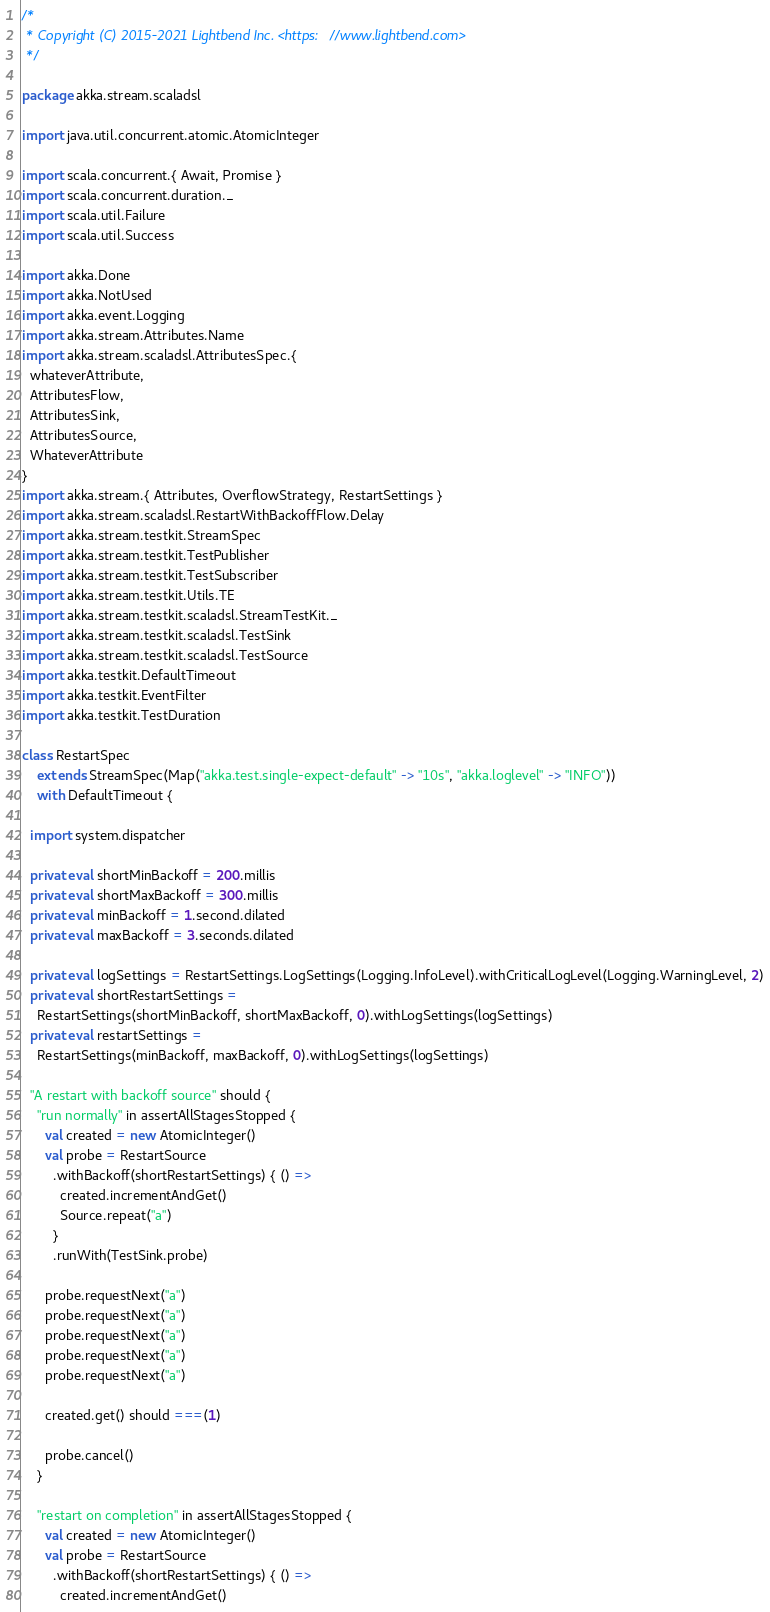<code> <loc_0><loc_0><loc_500><loc_500><_Scala_>/*
 * Copyright (C) 2015-2021 Lightbend Inc. <https://www.lightbend.com>
 */

package akka.stream.scaladsl

import java.util.concurrent.atomic.AtomicInteger

import scala.concurrent.{ Await, Promise }
import scala.concurrent.duration._
import scala.util.Failure
import scala.util.Success

import akka.Done
import akka.NotUsed
import akka.event.Logging
import akka.stream.Attributes.Name
import akka.stream.scaladsl.AttributesSpec.{
  whateverAttribute,
  AttributesFlow,
  AttributesSink,
  AttributesSource,
  WhateverAttribute
}
import akka.stream.{ Attributes, OverflowStrategy, RestartSettings }
import akka.stream.scaladsl.RestartWithBackoffFlow.Delay
import akka.stream.testkit.StreamSpec
import akka.stream.testkit.TestPublisher
import akka.stream.testkit.TestSubscriber
import akka.stream.testkit.Utils.TE
import akka.stream.testkit.scaladsl.StreamTestKit._
import akka.stream.testkit.scaladsl.TestSink
import akka.stream.testkit.scaladsl.TestSource
import akka.testkit.DefaultTimeout
import akka.testkit.EventFilter
import akka.testkit.TestDuration

class RestartSpec
    extends StreamSpec(Map("akka.test.single-expect-default" -> "10s", "akka.loglevel" -> "INFO"))
    with DefaultTimeout {

  import system.dispatcher

  private val shortMinBackoff = 200.millis
  private val shortMaxBackoff = 300.millis
  private val minBackoff = 1.second.dilated
  private val maxBackoff = 3.seconds.dilated

  private val logSettings = RestartSettings.LogSettings(Logging.InfoLevel).withCriticalLogLevel(Logging.WarningLevel, 2)
  private val shortRestartSettings =
    RestartSettings(shortMinBackoff, shortMaxBackoff, 0).withLogSettings(logSettings)
  private val restartSettings =
    RestartSettings(minBackoff, maxBackoff, 0).withLogSettings(logSettings)

  "A restart with backoff source" should {
    "run normally" in assertAllStagesStopped {
      val created = new AtomicInteger()
      val probe = RestartSource
        .withBackoff(shortRestartSettings) { () =>
          created.incrementAndGet()
          Source.repeat("a")
        }
        .runWith(TestSink.probe)

      probe.requestNext("a")
      probe.requestNext("a")
      probe.requestNext("a")
      probe.requestNext("a")
      probe.requestNext("a")

      created.get() should ===(1)

      probe.cancel()
    }

    "restart on completion" in assertAllStagesStopped {
      val created = new AtomicInteger()
      val probe = RestartSource
        .withBackoff(shortRestartSettings) { () =>
          created.incrementAndGet()</code> 